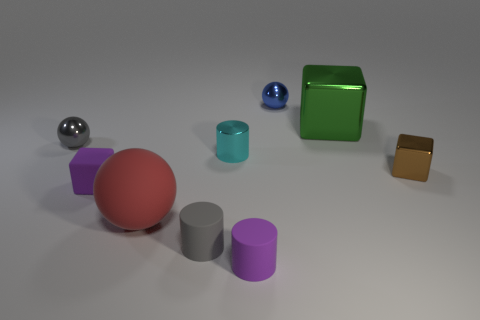Imagine these objects are part of a child's toy set. Which ones could represent characters due to their shape or color? Imagining these as part of a child's toy set, the red sphere could be a character due to its bright, inviting color, often associated with a protagonist. The green metallic cube could be an antagonist with its bold and uncommon color, suggesting a character with a different role. 